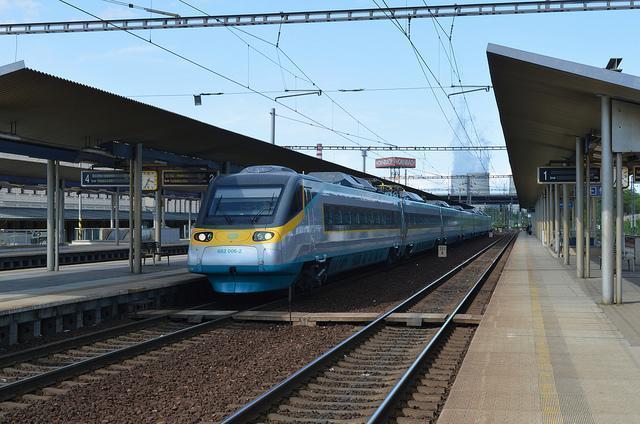What is the item closest to the green sign on the left that has the number 4 on it?
From the following four choices, select the correct answer to address the question.
Options: Train, track, briefcase, clock. Clock. 